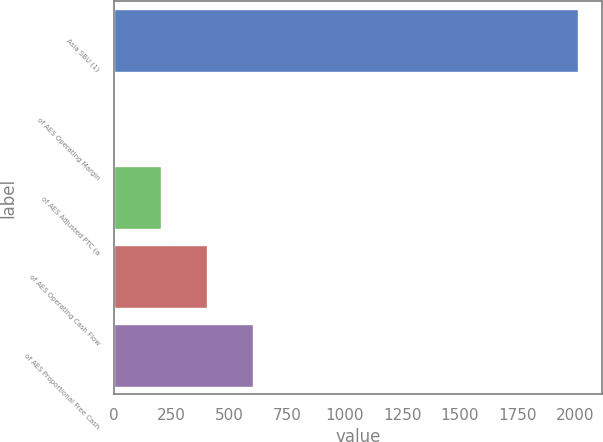Convert chart. <chart><loc_0><loc_0><loc_500><loc_500><bar_chart><fcel>Asia SBU (1)<fcel>of AES Operating Margin<fcel>of AES Adjusted PTC (a<fcel>of AES Operating Cash Flow<fcel>of AES Proportional Free Cash<nl><fcel>2014<fcel>2<fcel>203.2<fcel>404.4<fcel>605.6<nl></chart> 